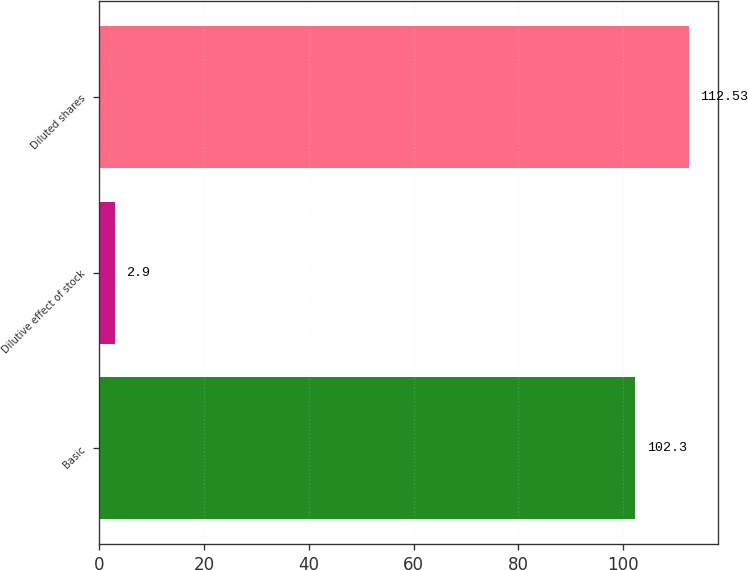<chart> <loc_0><loc_0><loc_500><loc_500><bar_chart><fcel>Basic<fcel>Dilutive effect of stock<fcel>Diluted shares<nl><fcel>102.3<fcel>2.9<fcel>112.53<nl></chart> 